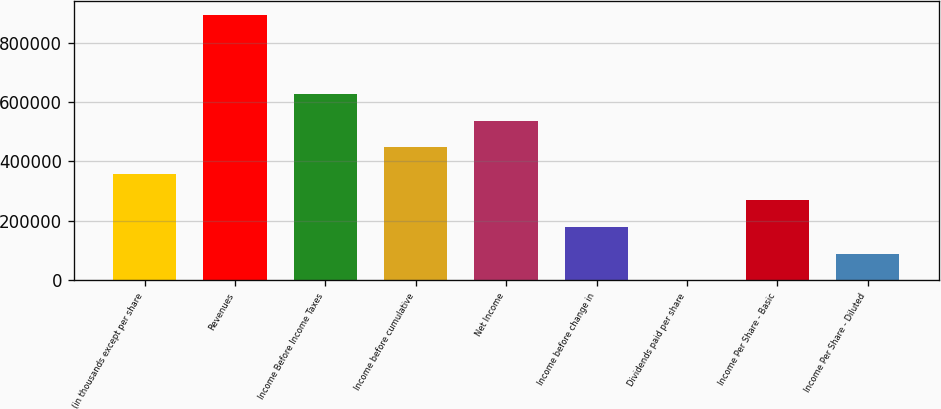<chart> <loc_0><loc_0><loc_500><loc_500><bar_chart><fcel>(in thousands except per share<fcel>Revenues<fcel>Income Before Income Taxes<fcel>Income before cumulative<fcel>Net Income<fcel>Income before change in<fcel>Dividends paid per share<fcel>Income Per Share - Basic<fcel>Income Per Share - Diluted<nl><fcel>357968<fcel>894920<fcel>626444<fcel>447460<fcel>536952<fcel>178984<fcel>0.2<fcel>268476<fcel>89492.2<nl></chart> 